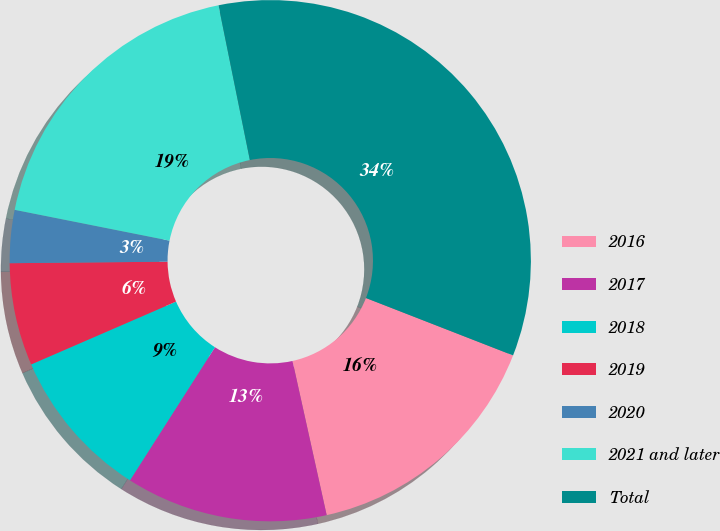Convert chart. <chart><loc_0><loc_0><loc_500><loc_500><pie_chart><fcel>2016<fcel>2017<fcel>2018<fcel>2019<fcel>2020<fcel>2021 and later<fcel>Total<nl><fcel>15.61%<fcel>12.52%<fcel>9.44%<fcel>6.36%<fcel>3.28%<fcel>18.69%<fcel>34.1%<nl></chart> 